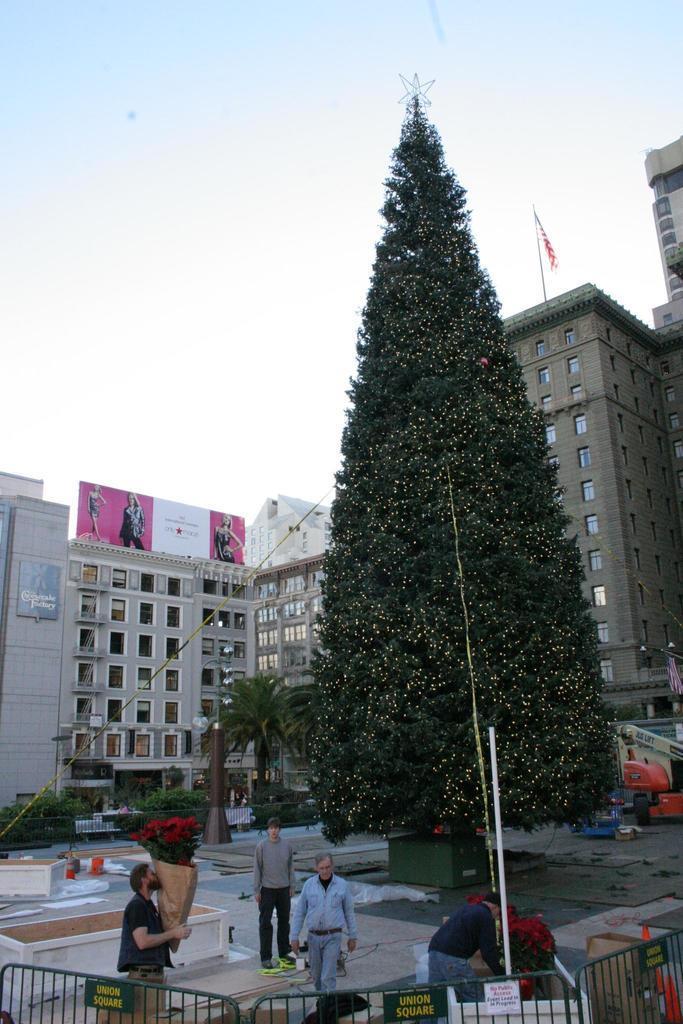Please provide a concise description of this image. In the picture we can see some buildings with windows and near to it, we can see some plants and a tree which is decorated with lights and near it, we can see four men, one man is holding some flower, one man is arranging it and one man is standing and one man is walking and in the background we can see the sky. 